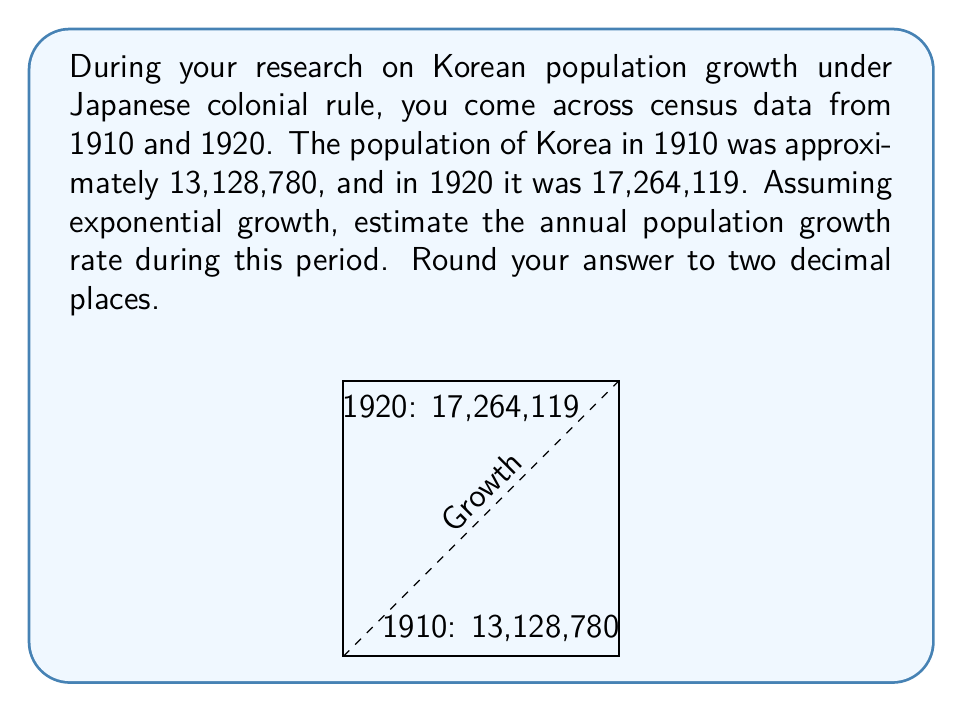Teach me how to tackle this problem. To solve this problem, we'll use the exponential growth formula:

$$P(t) = P_0 \cdot e^{rt}$$

Where:
$P(t)$ is the population at time $t$
$P_0$ is the initial population
$r$ is the annual growth rate
$t$ is the time in years

We know:
$P_0 = 13,128,780$ (population in 1910)
$P(10) = 17,264,119$ (population in 1920)
$t = 10$ years

Let's substitute these values into the formula:

$$17,264,119 = 13,128,780 \cdot e^{10r}$$

Now, let's solve for $r$:

1) Divide both sides by 13,128,780:
   $$\frac{17,264,119}{13,128,780} = e^{10r}$$

2) Take the natural log of both sides:
   $$\ln(\frac{17,264,119}{13,128,780}) = 10r$$

3) Solve for $r$:
   $$r = \frac{\ln(\frac{17,264,119}{13,128,780})}{10}$$

4) Calculate:
   $$r = \frac{\ln(1.3150)}{10} \approx 0.02737$$

5) Convert to a percentage and round to two decimal places:
   $$r \approx 2.74\%$$

Therefore, the estimated annual population growth rate was approximately 2.74%.
Answer: 2.74% 